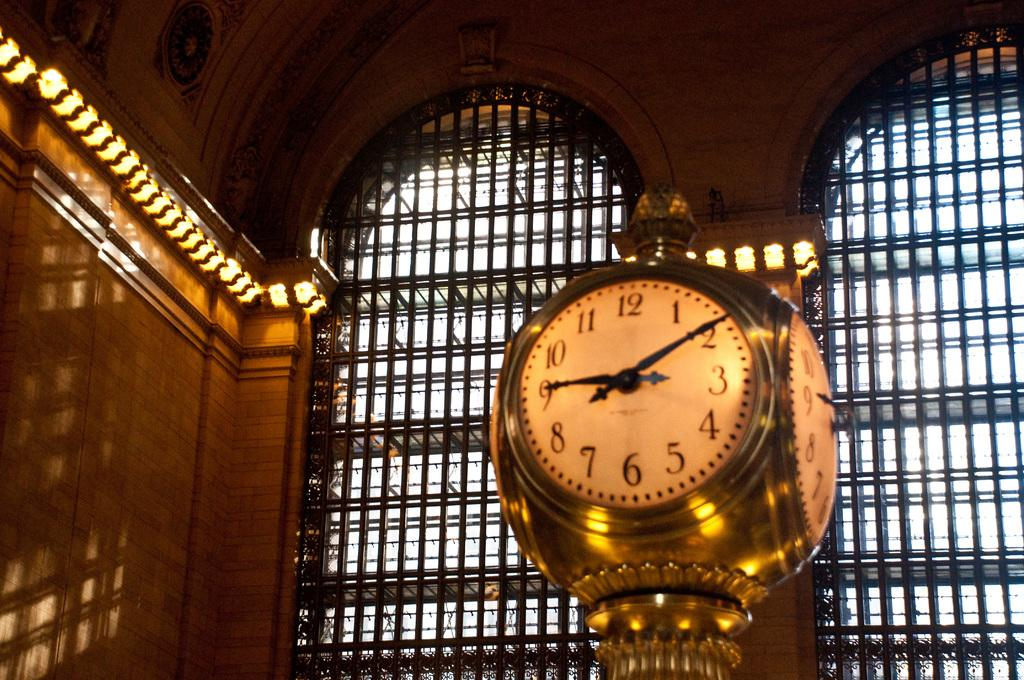<image>
Render a clear and concise summary of the photo. The clock inside the building shows the time as 9:10. 